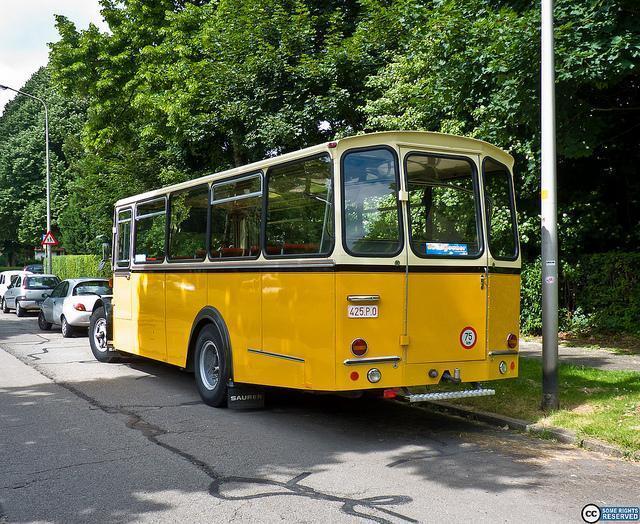How many cars are in front of the trolley?
Give a very brief answer. 3. 